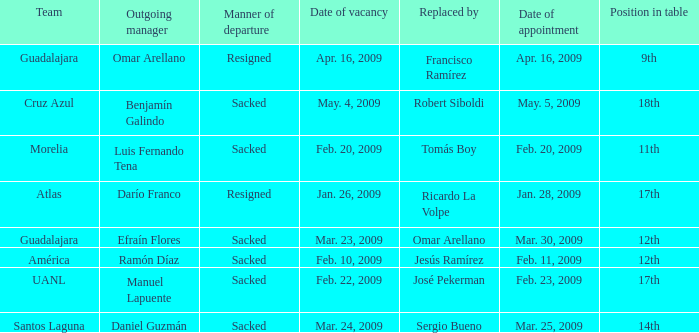What is Team, when Replaced By is "Jesús Ramírez"? América. 